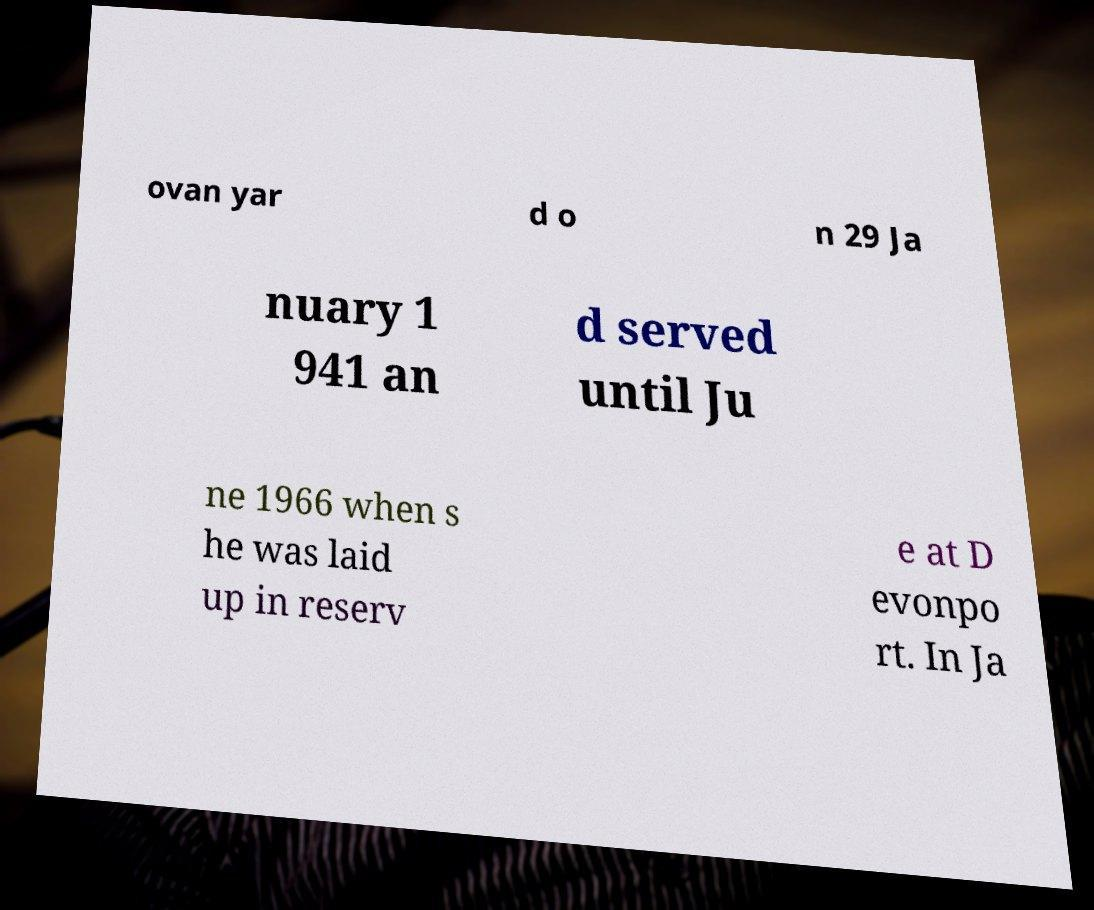Can you read and provide the text displayed in the image?This photo seems to have some interesting text. Can you extract and type it out for me? ovan yar d o n 29 Ja nuary 1 941 an d served until Ju ne 1966 when s he was laid up in reserv e at D evonpo rt. In Ja 